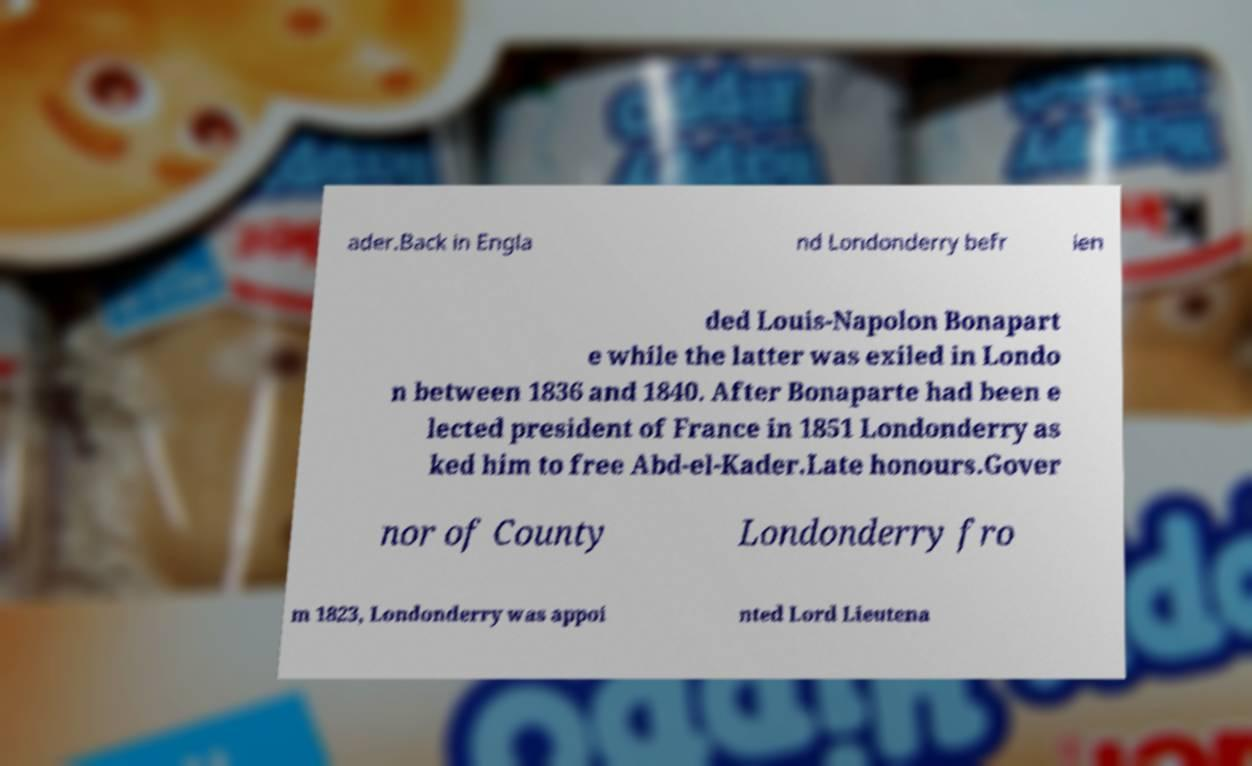What messages or text are displayed in this image? I need them in a readable, typed format. ader.Back in Engla nd Londonderry befr ien ded Louis-Napolon Bonapart e while the latter was exiled in Londo n between 1836 and 1840. After Bonaparte had been e lected president of France in 1851 Londonderry as ked him to free Abd-el-Kader.Late honours.Gover nor of County Londonderry fro m 1823, Londonderry was appoi nted Lord Lieutena 